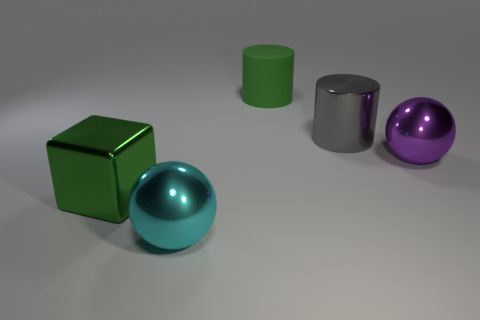Add 4 big cyan spheres. How many objects exist? 9 Subtract all balls. How many objects are left? 3 Subtract all big cyan metal balls. Subtract all large matte objects. How many objects are left? 3 Add 1 green metallic things. How many green metallic things are left? 2 Add 4 balls. How many balls exist? 6 Subtract 0 gray spheres. How many objects are left? 5 